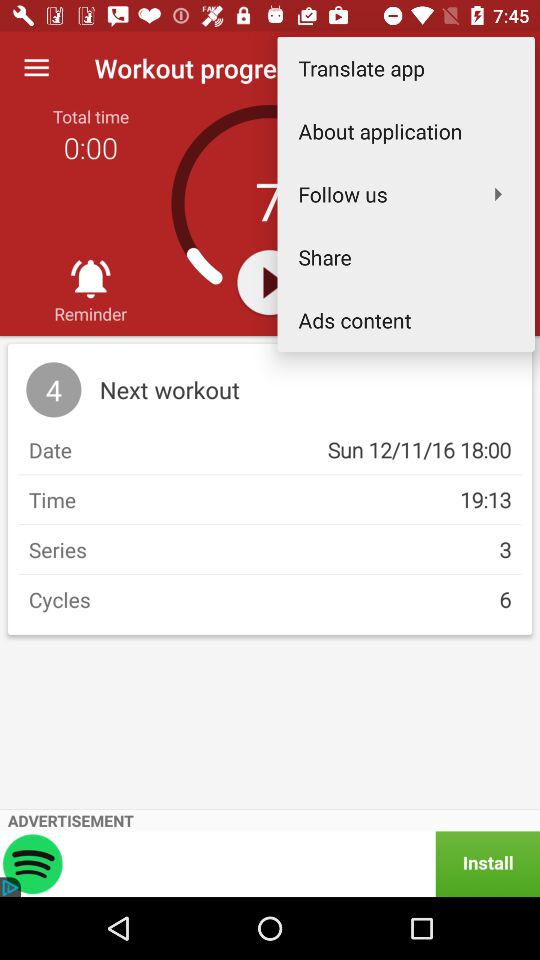How many more cycles than series are there?
Answer the question using a single word or phrase. 3 